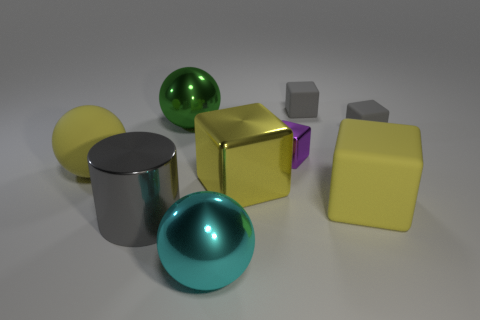Subtract all small rubber cubes. How many cubes are left? 3 Subtract all gray cubes. How many cubes are left? 3 Subtract 4 blocks. How many blocks are left? 1 Subtract all gray spheres. How many yellow cubes are left? 2 Subtract all small brown metallic things. Subtract all small rubber blocks. How many objects are left? 7 Add 8 yellow metallic cubes. How many yellow metallic cubes are left? 9 Add 5 large purple metallic cylinders. How many large purple metallic cylinders exist? 5 Subtract 1 cyan spheres. How many objects are left? 8 Subtract all blocks. How many objects are left? 4 Subtract all red balls. Subtract all purple cylinders. How many balls are left? 3 